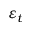<formula> <loc_0><loc_0><loc_500><loc_500>\varepsilon _ { t }</formula> 